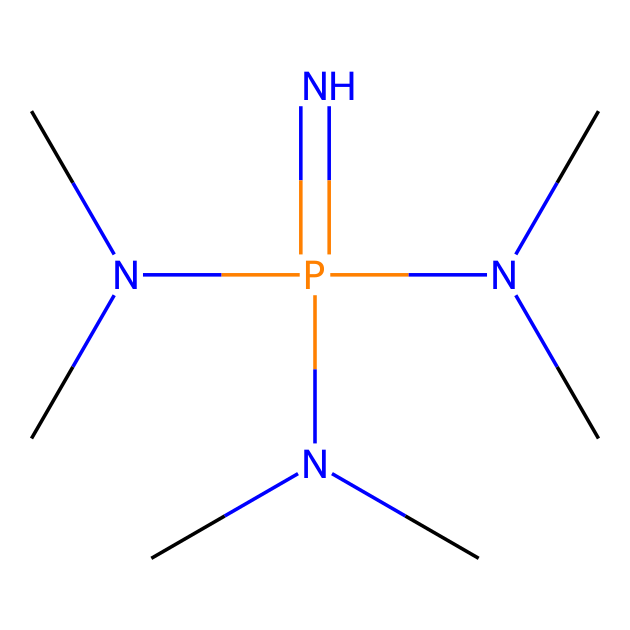What is the central atom in this compound? The central atom in this compound is phosphorus, indicated by the 'P' in the SMILES notation. The structure shows nitrogen atoms surrounding the central phosphorus atom.
Answer: phosphorus How many nitrogen atoms are present in the compound? By analyzing the SMILES representation, there are three 'N' symbols, indicating three nitrogen atoms in the structure.
Answer: three What type of bonding is expected between the phosphorus and nitrogen atoms? The phosphorus and nitrogen atoms are connected by covalent bonds, as evidenced by the typical bonding behavior of these elements in chemical structures.
Answer: covalent What is the overall charge of the compound? This compound is neutral; it contains no charged species in its SMILES representation, and the balance of atoms suggests neutrality.
Answer: neutral Which groups are present in the compound that contribute to its basicity? The presence of tertiary amine groups (from the N(C)C) contributes to basicity, as these groups can accept protons easily.
Answer: tertiary amine What is the functional group characteristic of this compound that makes it a superbases? The presence of phosphazene, identified by the central phosphorus atom bonded to multiple nitrogen atoms, characterizes it as a superbasic compound.
Answer: phosphazene How many carbon atoms are attached to the nitrogen atoms in the compound? There are six carbon atoms shown in the SMILES notation, indicated by the presence of 'C' next to each nitrogen. Each nitrogen is bonded to a carbon, leading to a total of six.
Answer: six 